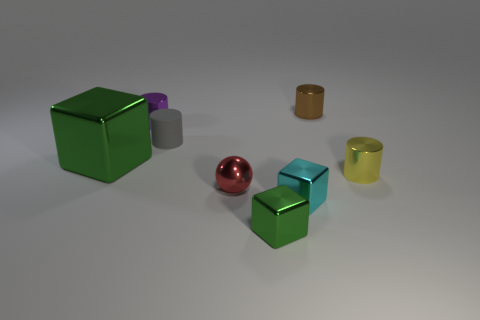How many objects are there, and can you describe their shapes? There are six objects in the image. There's a large green cube, a small green cube, a purple cylinder, a red sphere, a gold cylinder, and a translucent yellow cylinder. 